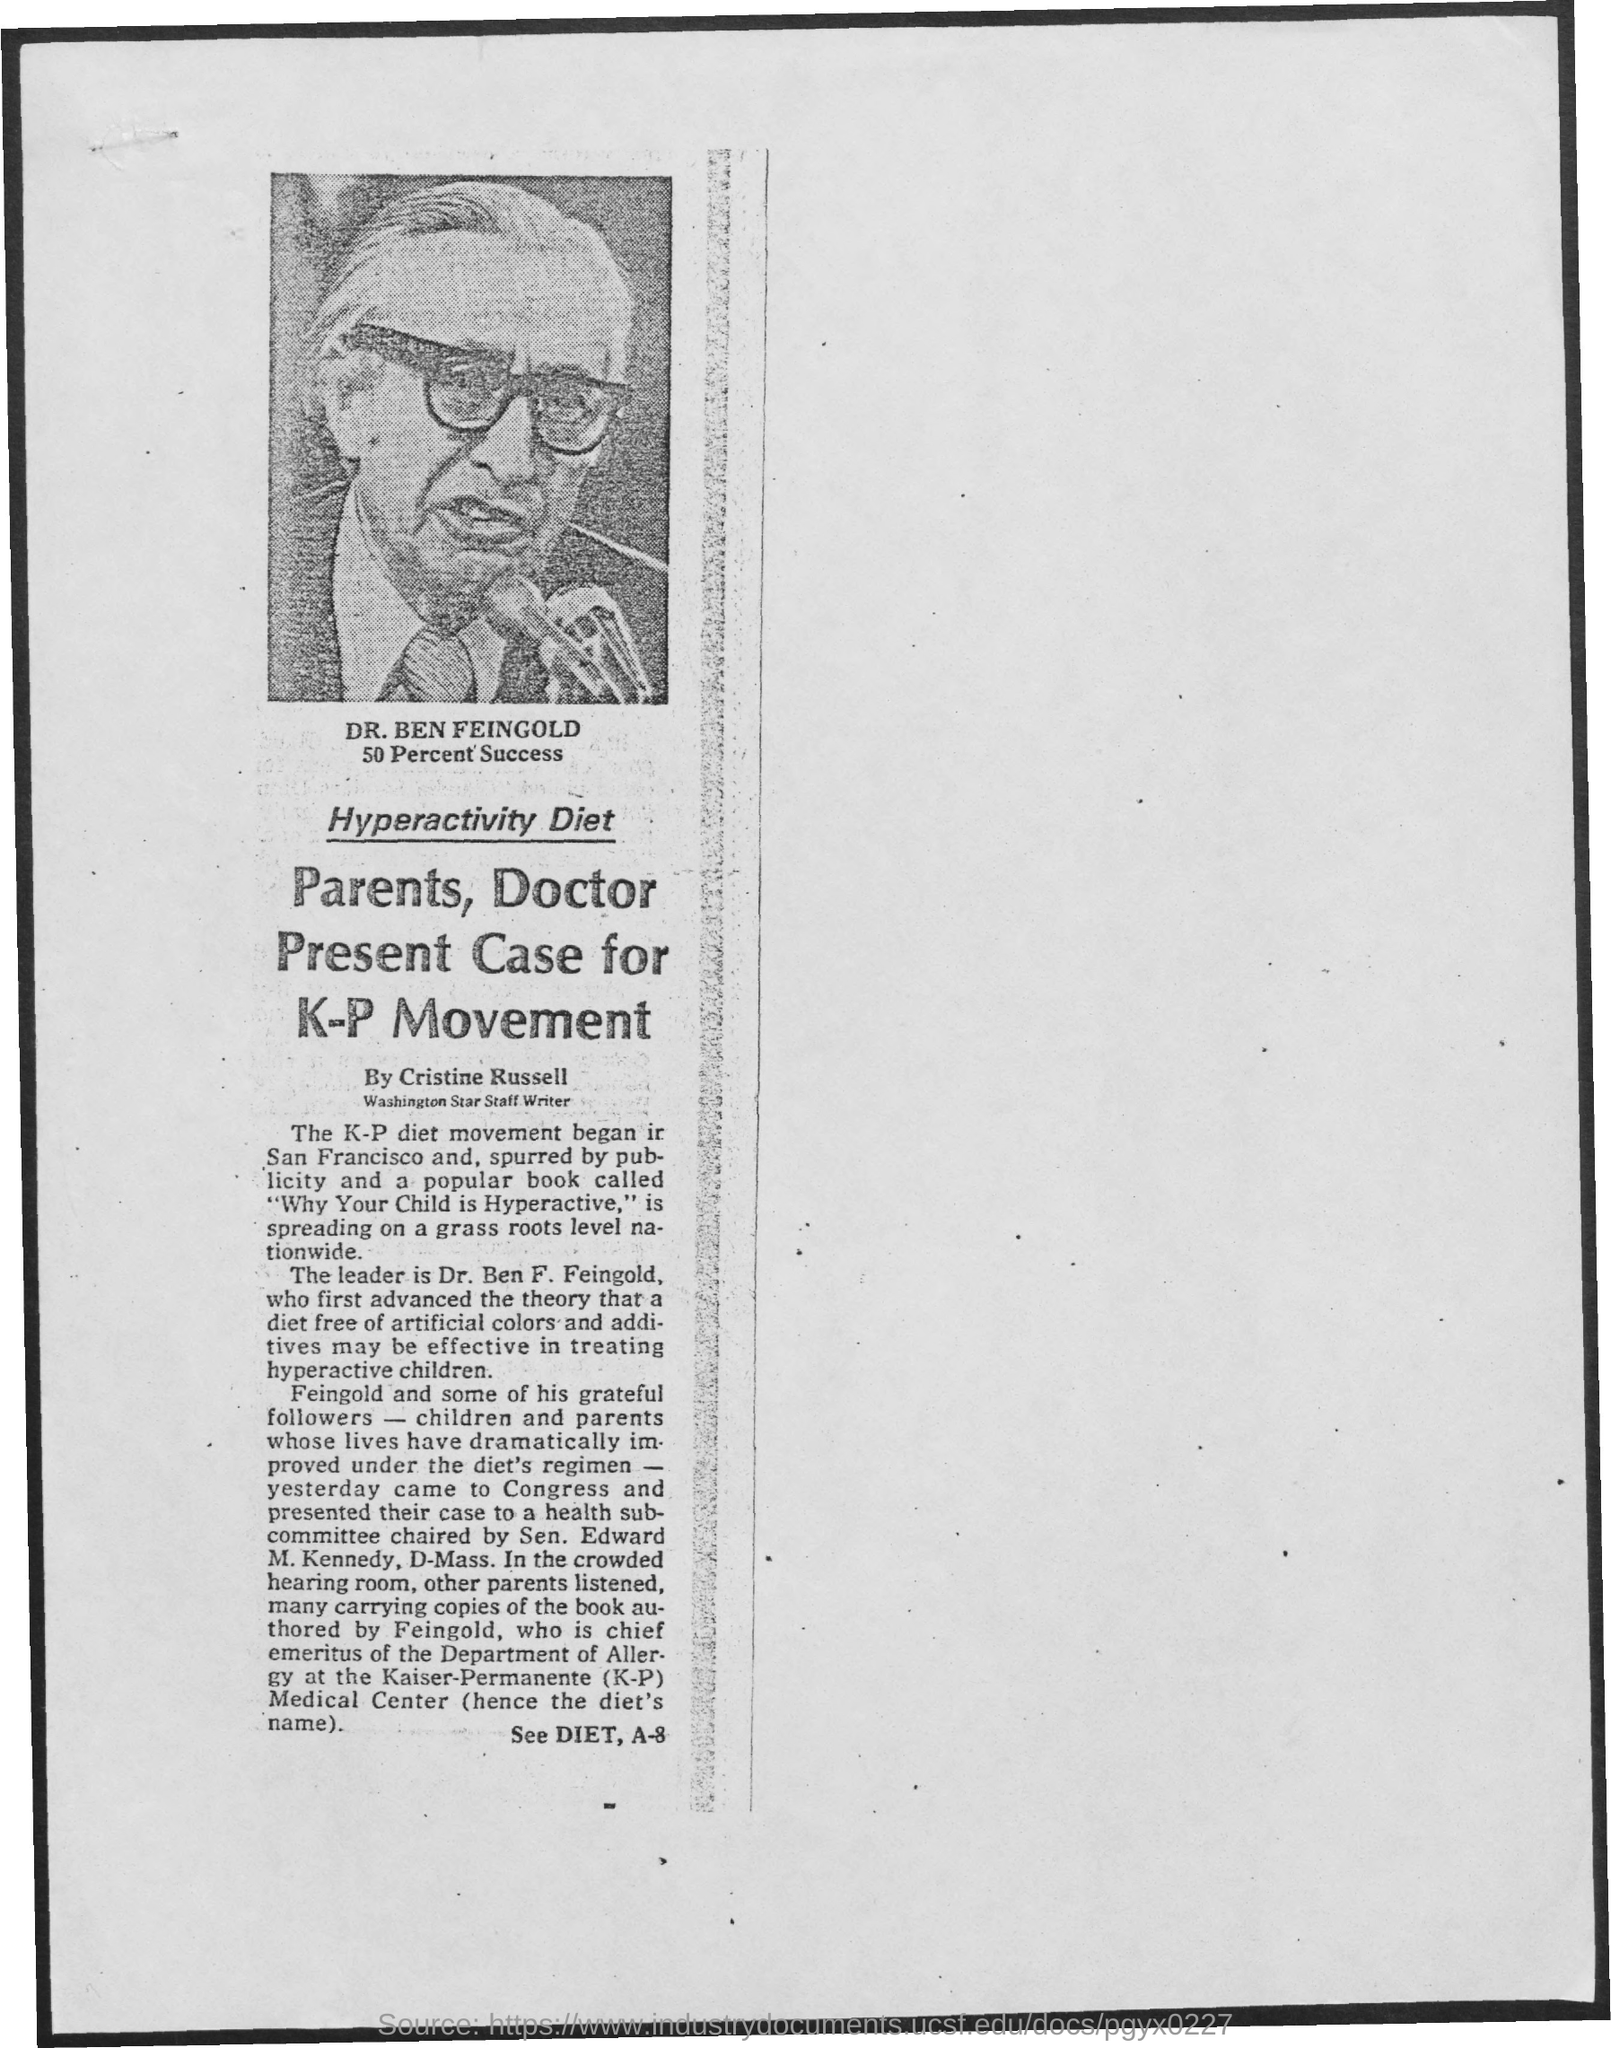Draw attention to some important aspects in this diagram. Cristine Russell is the author of the article. The K-P movement is supported by parents and medical professionals. 